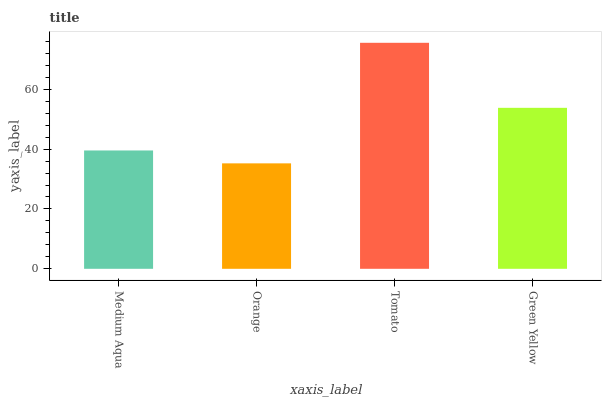Is Orange the minimum?
Answer yes or no. Yes. Is Tomato the maximum?
Answer yes or no. Yes. Is Tomato the minimum?
Answer yes or no. No. Is Orange the maximum?
Answer yes or no. No. Is Tomato greater than Orange?
Answer yes or no. Yes. Is Orange less than Tomato?
Answer yes or no. Yes. Is Orange greater than Tomato?
Answer yes or no. No. Is Tomato less than Orange?
Answer yes or no. No. Is Green Yellow the high median?
Answer yes or no. Yes. Is Medium Aqua the low median?
Answer yes or no. Yes. Is Orange the high median?
Answer yes or no. No. Is Orange the low median?
Answer yes or no. No. 